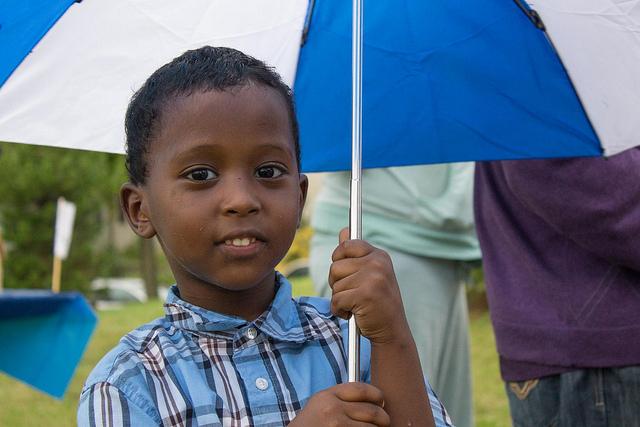What is the boy holding?
Keep it brief. Umbrella. Is his top button buttoned?
Answer briefly. Yes. Is the child going to be a doctor?
Answer briefly. No. Are the colors in the boy's umbrella similar to the colors in his shirt?
Quick response, please. Yes. How many boys are in the photo?
Concise answer only. 1. 